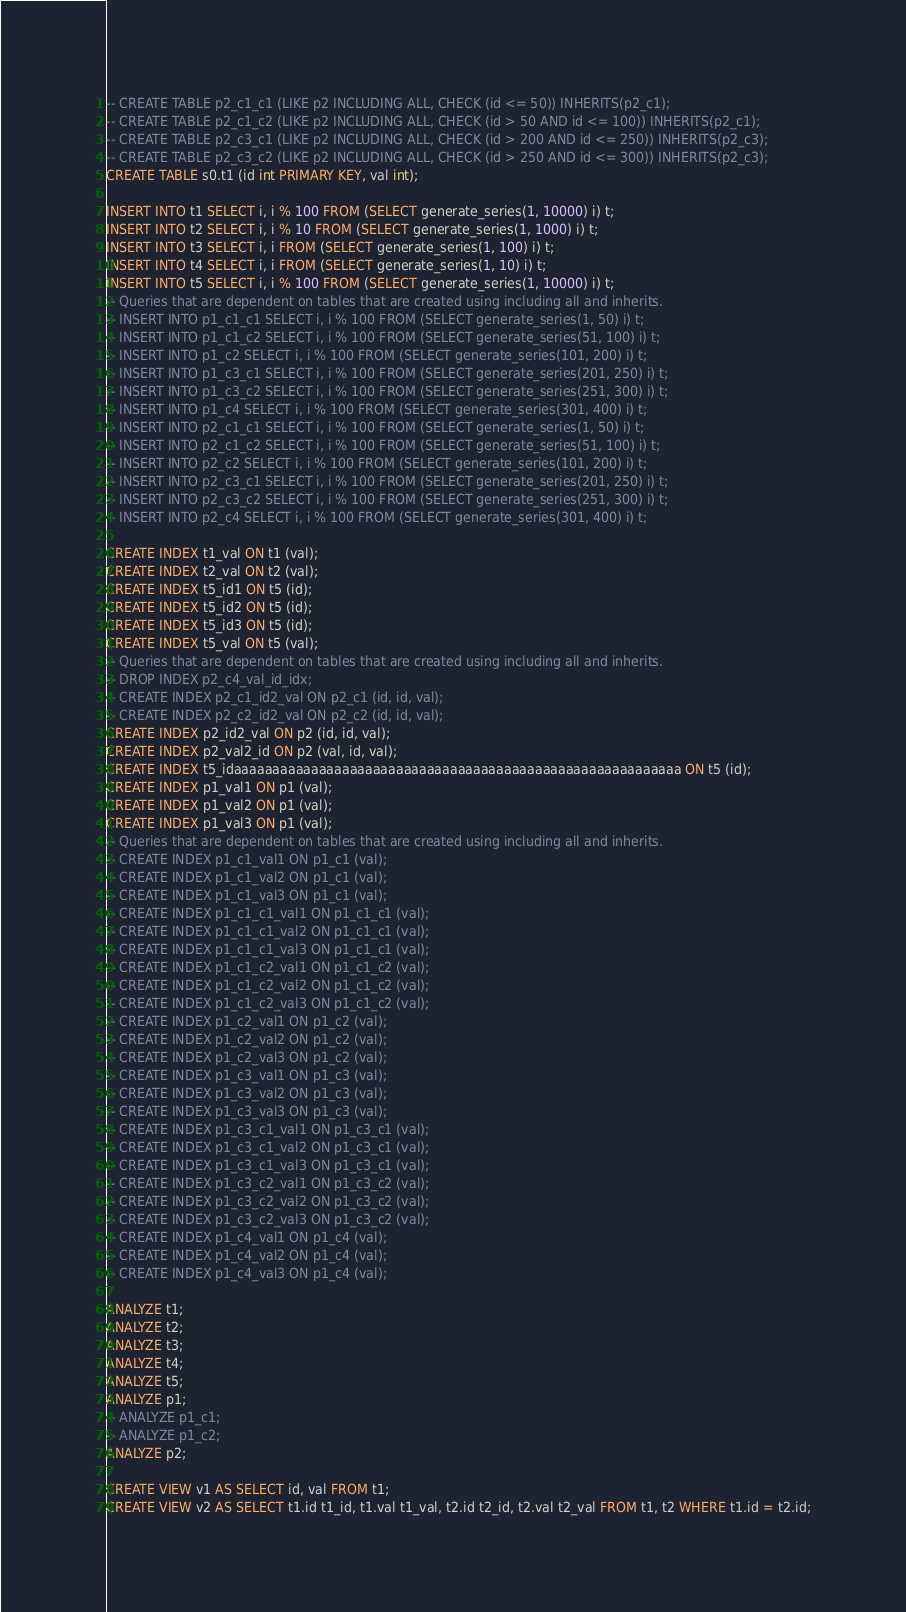Convert code to text. <code><loc_0><loc_0><loc_500><loc_500><_SQL_>-- CREATE TABLE p2_c1_c1 (LIKE p2 INCLUDING ALL, CHECK (id <= 50)) INHERITS(p2_c1);
-- CREATE TABLE p2_c1_c2 (LIKE p2 INCLUDING ALL, CHECK (id > 50 AND id <= 100)) INHERITS(p2_c1);
-- CREATE TABLE p2_c3_c1 (LIKE p2 INCLUDING ALL, CHECK (id > 200 AND id <= 250)) INHERITS(p2_c3);
-- CREATE TABLE p2_c3_c2 (LIKE p2 INCLUDING ALL, CHECK (id > 250 AND id <= 300)) INHERITS(p2_c3);
CREATE TABLE s0.t1 (id int PRIMARY KEY, val int);

INSERT INTO t1 SELECT i, i % 100 FROM (SELECT generate_series(1, 10000) i) t;
INSERT INTO t2 SELECT i, i % 10 FROM (SELECT generate_series(1, 1000) i) t;
INSERT INTO t3 SELECT i, i FROM (SELECT generate_series(1, 100) i) t;
INSERT INTO t4 SELECT i, i FROM (SELECT generate_series(1, 10) i) t;
INSERT INTO t5 SELECT i, i % 100 FROM (SELECT generate_series(1, 10000) i) t;
-- Queries that are dependent on tables that are created using including all and inherits.
-- INSERT INTO p1_c1_c1 SELECT i, i % 100 FROM (SELECT generate_series(1, 50) i) t;
-- INSERT INTO p1_c1_c2 SELECT i, i % 100 FROM (SELECT generate_series(51, 100) i) t;
-- INSERT INTO p1_c2 SELECT i, i % 100 FROM (SELECT generate_series(101, 200) i) t;
-- INSERT INTO p1_c3_c1 SELECT i, i % 100 FROM (SELECT generate_series(201, 250) i) t;
-- INSERT INTO p1_c3_c2 SELECT i, i % 100 FROM (SELECT generate_series(251, 300) i) t;
-- INSERT INTO p1_c4 SELECT i, i % 100 FROM (SELECT generate_series(301, 400) i) t;
-- INSERT INTO p2_c1_c1 SELECT i, i % 100 FROM (SELECT generate_series(1, 50) i) t;
-- INSERT INTO p2_c1_c2 SELECT i, i % 100 FROM (SELECT generate_series(51, 100) i) t;
-- INSERT INTO p2_c2 SELECT i, i % 100 FROM (SELECT generate_series(101, 200) i) t;
-- INSERT INTO p2_c3_c1 SELECT i, i % 100 FROM (SELECT generate_series(201, 250) i) t;
-- INSERT INTO p2_c3_c2 SELECT i, i % 100 FROM (SELECT generate_series(251, 300) i) t;
-- INSERT INTO p2_c4 SELECT i, i % 100 FROM (SELECT generate_series(301, 400) i) t;

CREATE INDEX t1_val ON t1 (val);
CREATE INDEX t2_val ON t2 (val);
CREATE INDEX t5_id1 ON t5 (id);
CREATE INDEX t5_id2 ON t5 (id);
CREATE INDEX t5_id3 ON t5 (id);
CREATE INDEX t5_val ON t5 (val);
-- Queries that are dependent on tables that are created using including all and inherits.
-- DROP INDEX p2_c4_val_id_idx;
-- CREATE INDEX p2_c1_id2_val ON p2_c1 (id, id, val);
-- CREATE INDEX p2_c2_id2_val ON p2_c2 (id, id, val);
CREATE INDEX p2_id2_val ON p2 (id, id, val);
CREATE INDEX p2_val2_id ON p2 (val, id, val);
CREATE INDEX t5_idaaaaaaaaaaaaaaaaaaaaaaaaaaaaaaaaaaaaaaaaaaaaaaaaaaaaaaaaaa ON t5 (id);
CREATE INDEX p1_val1 ON p1 (val);
CREATE INDEX p1_val2 ON p1 (val);
CREATE INDEX p1_val3 ON p1 (val);
-- Queries that are dependent on tables that are created using including all and inherits.
-- CREATE INDEX p1_c1_val1 ON p1_c1 (val);
-- CREATE INDEX p1_c1_val2 ON p1_c1 (val);
-- CREATE INDEX p1_c1_val3 ON p1_c1 (val);
-- CREATE INDEX p1_c1_c1_val1 ON p1_c1_c1 (val);
-- CREATE INDEX p1_c1_c1_val2 ON p1_c1_c1 (val);
-- CREATE INDEX p1_c1_c1_val3 ON p1_c1_c1 (val);
-- CREATE INDEX p1_c1_c2_val1 ON p1_c1_c2 (val);
-- CREATE INDEX p1_c1_c2_val2 ON p1_c1_c2 (val);
-- CREATE INDEX p1_c1_c2_val3 ON p1_c1_c2 (val);
-- CREATE INDEX p1_c2_val1 ON p1_c2 (val);
-- CREATE INDEX p1_c2_val2 ON p1_c2 (val);
-- CREATE INDEX p1_c2_val3 ON p1_c2 (val);
-- CREATE INDEX p1_c3_val1 ON p1_c3 (val);
-- CREATE INDEX p1_c3_val2 ON p1_c3 (val);
-- CREATE INDEX p1_c3_val3 ON p1_c3 (val);
-- CREATE INDEX p1_c3_c1_val1 ON p1_c3_c1 (val);
-- CREATE INDEX p1_c3_c1_val2 ON p1_c3_c1 (val);
-- CREATE INDEX p1_c3_c1_val3 ON p1_c3_c1 (val);
-- CREATE INDEX p1_c3_c2_val1 ON p1_c3_c2 (val);
-- CREATE INDEX p1_c3_c2_val2 ON p1_c3_c2 (val);
-- CREATE INDEX p1_c3_c2_val3 ON p1_c3_c2 (val);
-- CREATE INDEX p1_c4_val1 ON p1_c4 (val);
-- CREATE INDEX p1_c4_val2 ON p1_c4 (val);
-- CREATE INDEX p1_c4_val3 ON p1_c4 (val);

ANALYZE t1;
ANALYZE t2;
ANALYZE t3;
ANALYZE t4;
ANALYZE t5;
ANALYZE p1;
-- ANALYZE p1_c1;
-- ANALYZE p1_c2;
ANALYZE p2;

CREATE VIEW v1 AS SELECT id, val FROM t1;
CREATE VIEW v2 AS SELECT t1.id t1_id, t1.val t1_val, t2.id t2_id, t2.val t2_val FROM t1, t2 WHERE t1.id = t2.id;</code> 